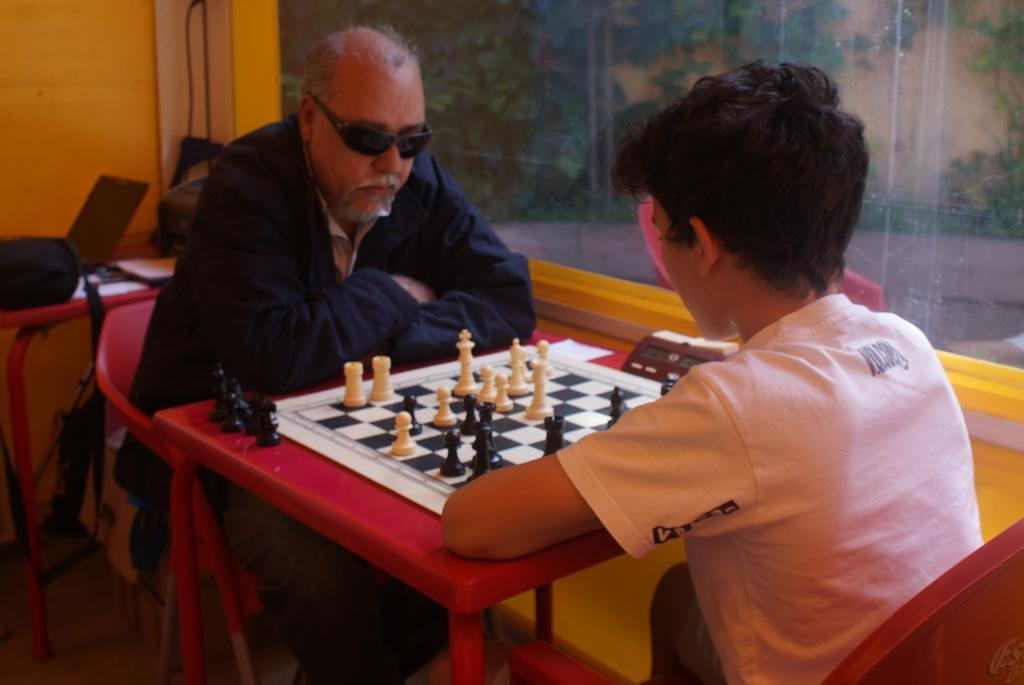Who is present in the image? There is a man and a boy in the image. What are they doing in the image? The man and boy are sitting on chairs and playing a chess board. Where is the chess board located? The chess board is placed on a table. What is used to keep track of time during their game? There is a timer associated with the chess board. What can be seen in the background of the image? In the background, there is a bag, papers, a wall with glass, and trees. What type of frog can be seen sitting on the chess board? There is no frog present in the image. 